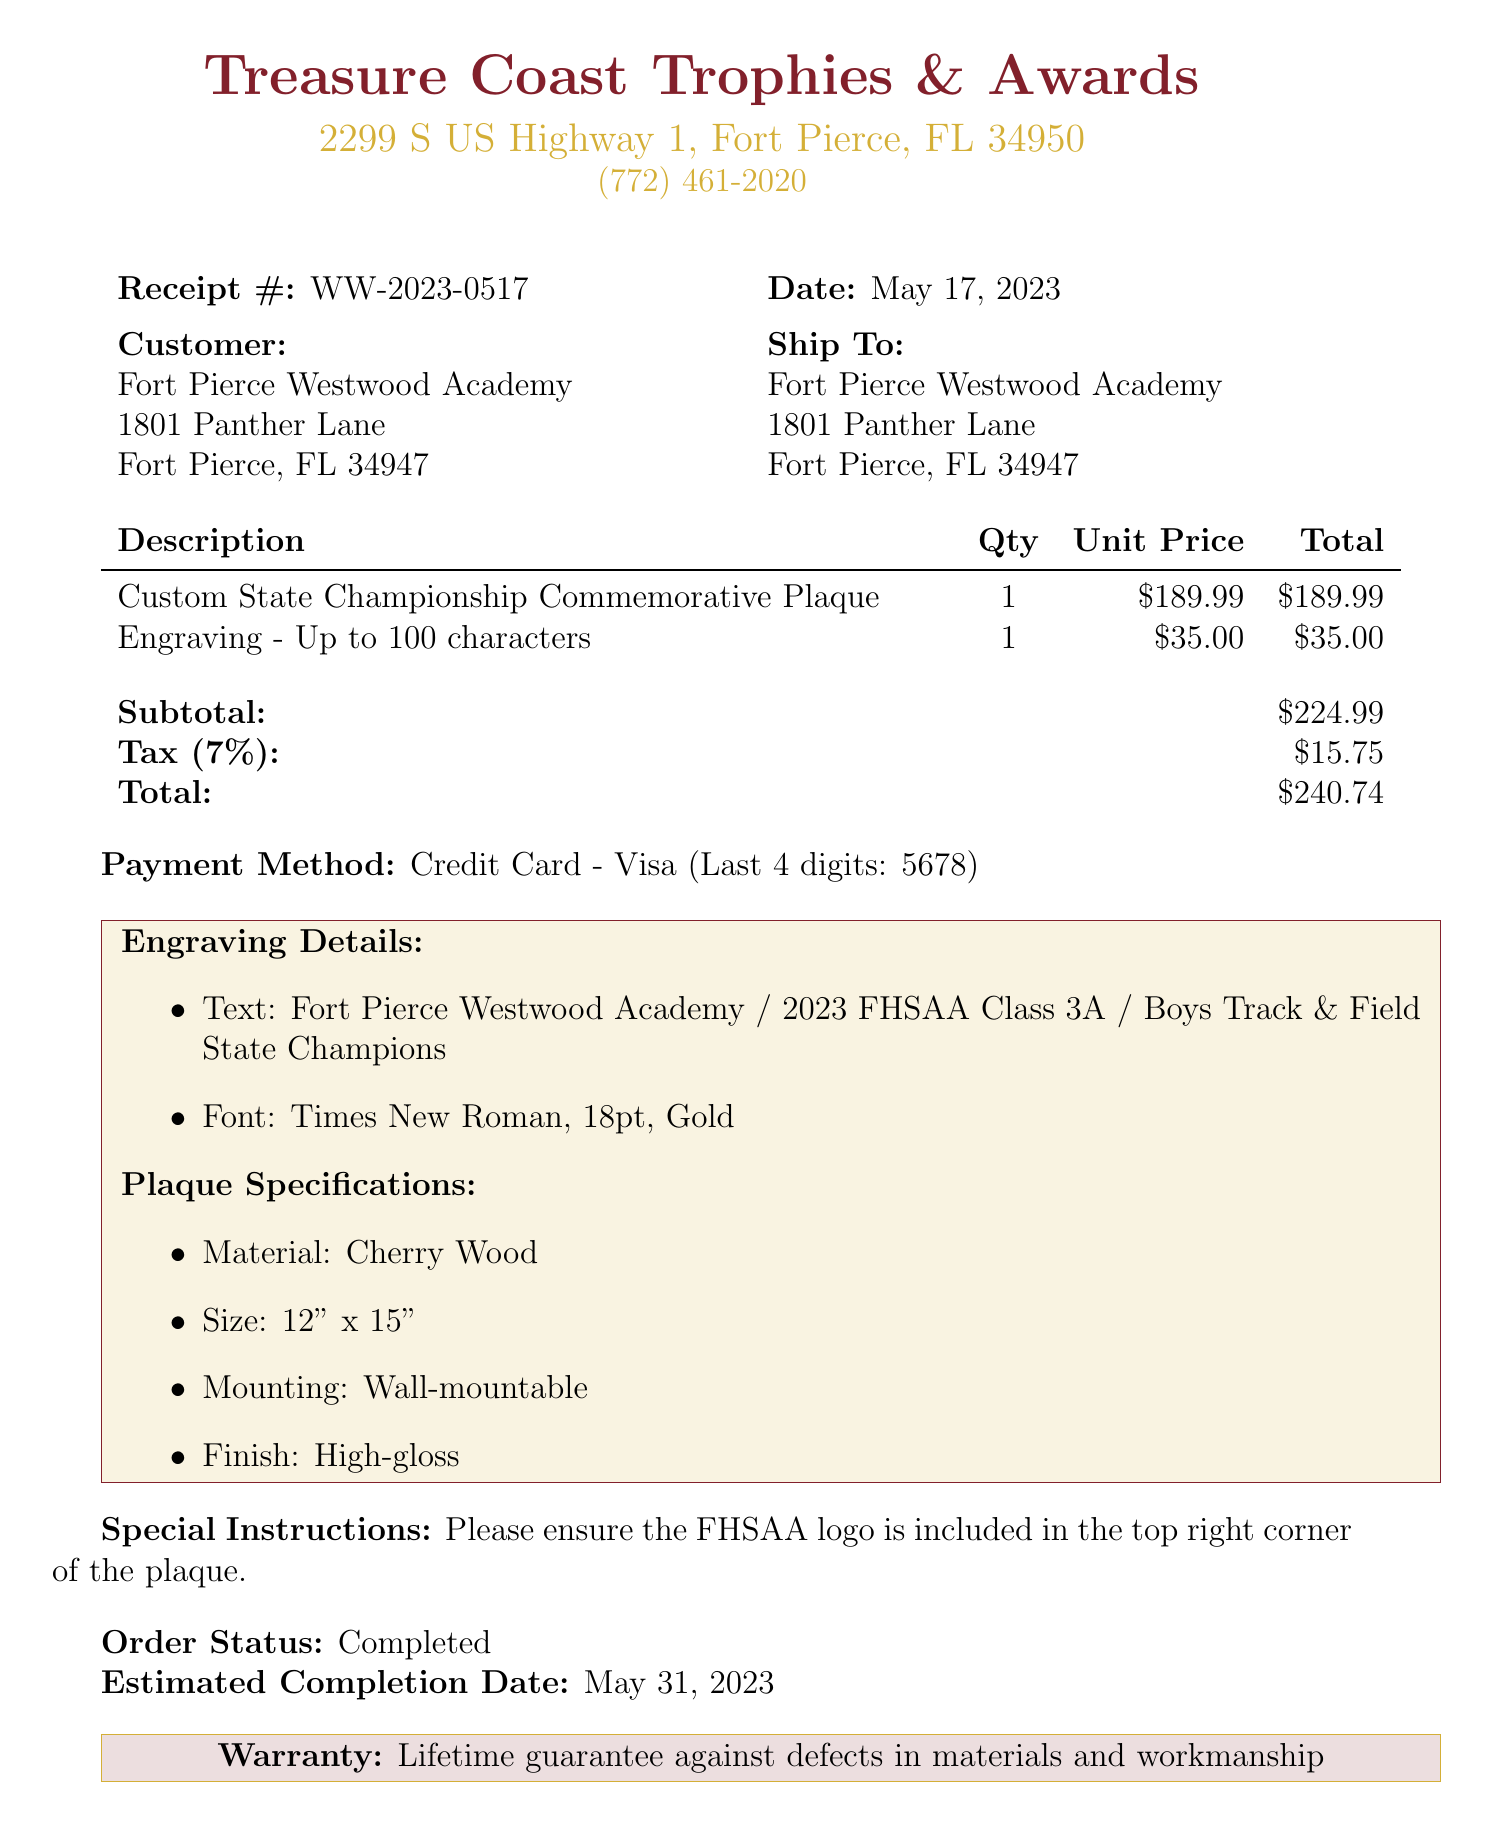What is the receipt number? The receipt number is indicated clearly at the top of the document.
Answer: WW-2023-0517 What is the date of the receipt? The date when the transaction was made is stated on the receipt.
Answer: May 17, 2023 Who is the vendor? The vendor's name is mentioned at the beginning of the document.
Answer: Treasure Coast Trophies & Awards What is the engraving font? The font used for the engraving is specified in the engraving details section.
Answer: Times New Roman What is the total amount charged? The total charge at the end of the document summarizes the amount after tax.
Answer: $240.74 How many items were purchased? The number of items purchased is mentioned in the itemized list.
Answer: 2 What is the special instruction given? The special instruction provides additional guidance for the order at the bottom of the document.
Answer: Please ensure the FHSAA logo is included in the top right corner of the plaque What is the warranty period? The warranty information is specified at the end of the receipt.
Answer: Lifetime guarantee against defects in materials and workmanship What is the tax rate applied? The tax rate is stated in the financial summary section of the receipt.
Answer: 7% 